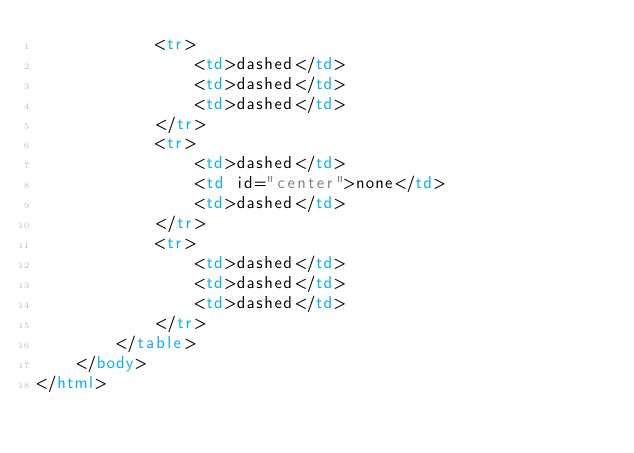Convert code to text. <code><loc_0><loc_0><loc_500><loc_500><_HTML_>            <tr>
                <td>dashed</td>
                <td>dashed</td>
                <td>dashed</td>
            </tr>
            <tr>
                <td>dashed</td>
                <td id="center">none</td>
                <td>dashed</td>
            </tr>
            <tr>
                <td>dashed</td>
                <td>dashed</td>
                <td>dashed</td>
            </tr>
        </table>
    </body>
</html></code> 